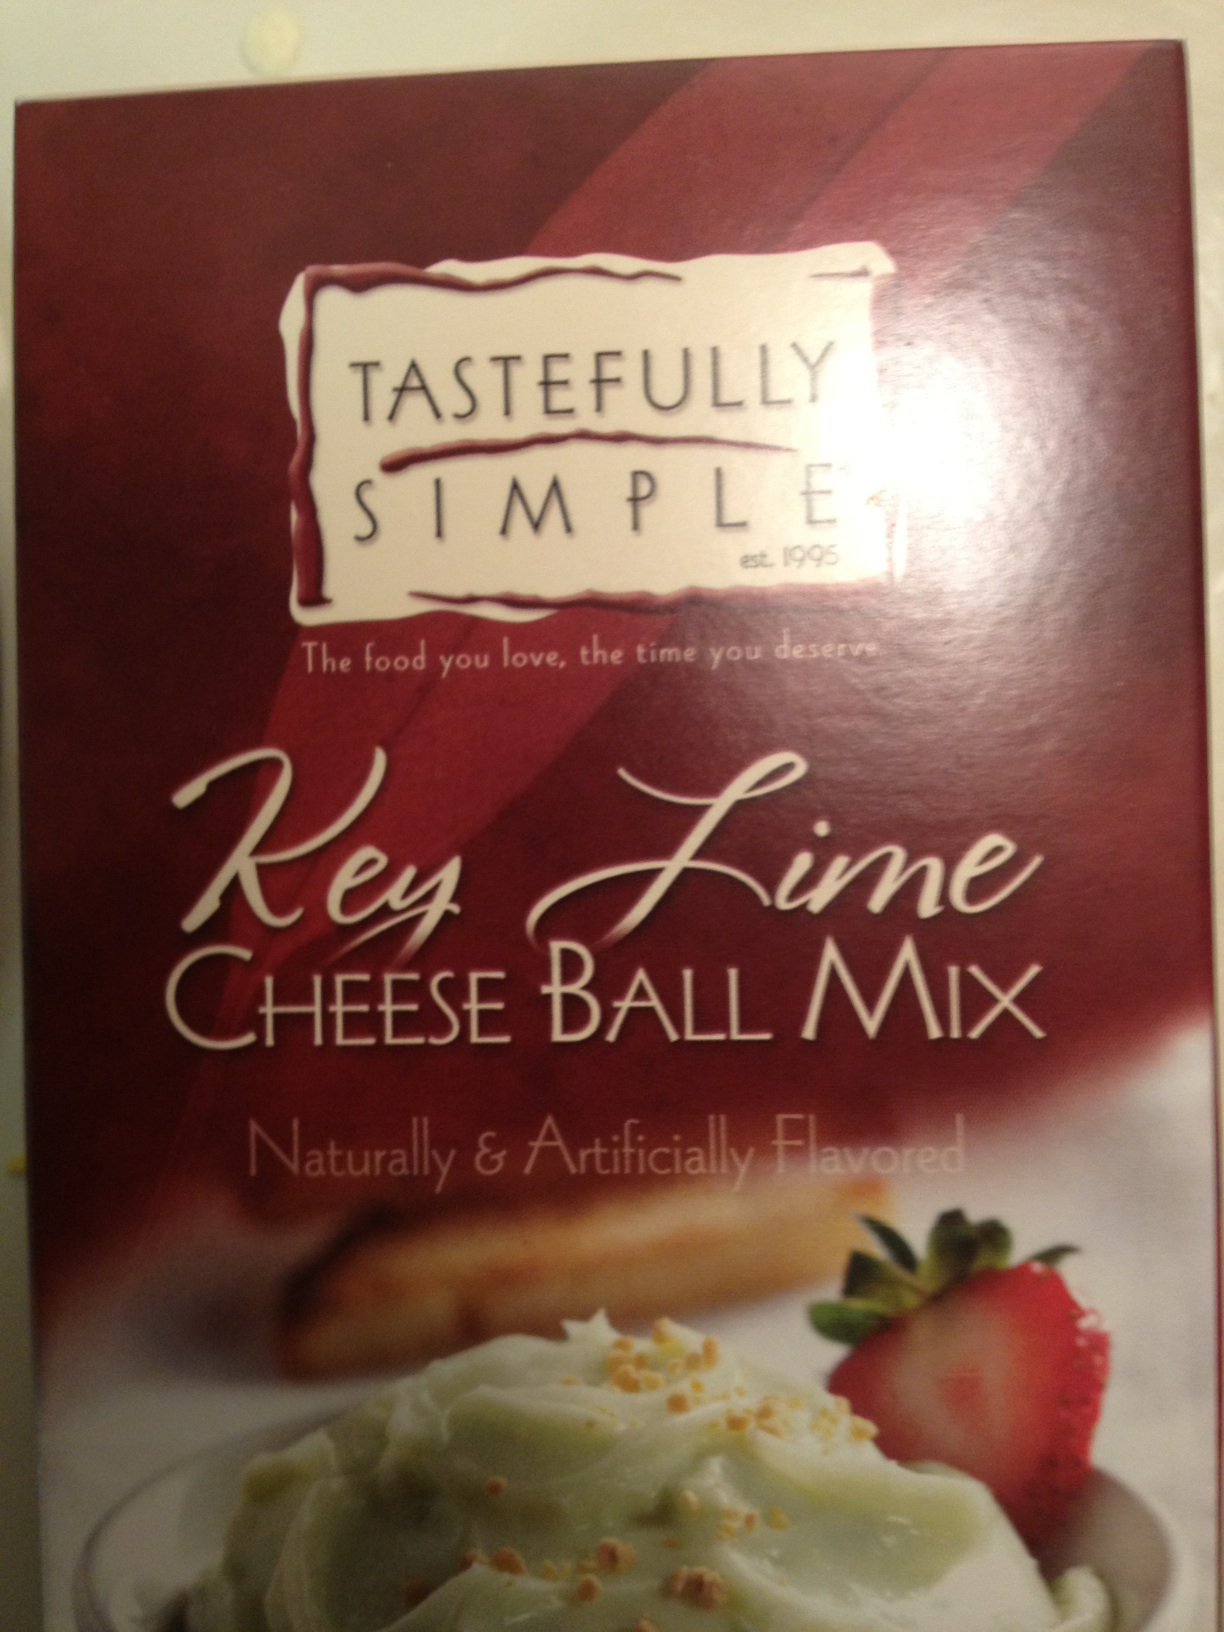Is this a new product and who typically buys it? Introduced by Tastefully Simple, which has been around since 1995, this product is tailored for those who enjoy unique and convenient dessert solutions. It is particularly popular among home cooks looking for quick, delightful additions to their party menu. Could you suggest other similar products by the same company? Certainly! Tastefully Simple also offers other dessert mixes such as 'Almond Pound Cake Mix', 'Truffle Fudge Brownie Mix', and savory meal solutions like 'Garlic Garlic Seasoning' and 'Bountiful Beer Bread Mix'. 